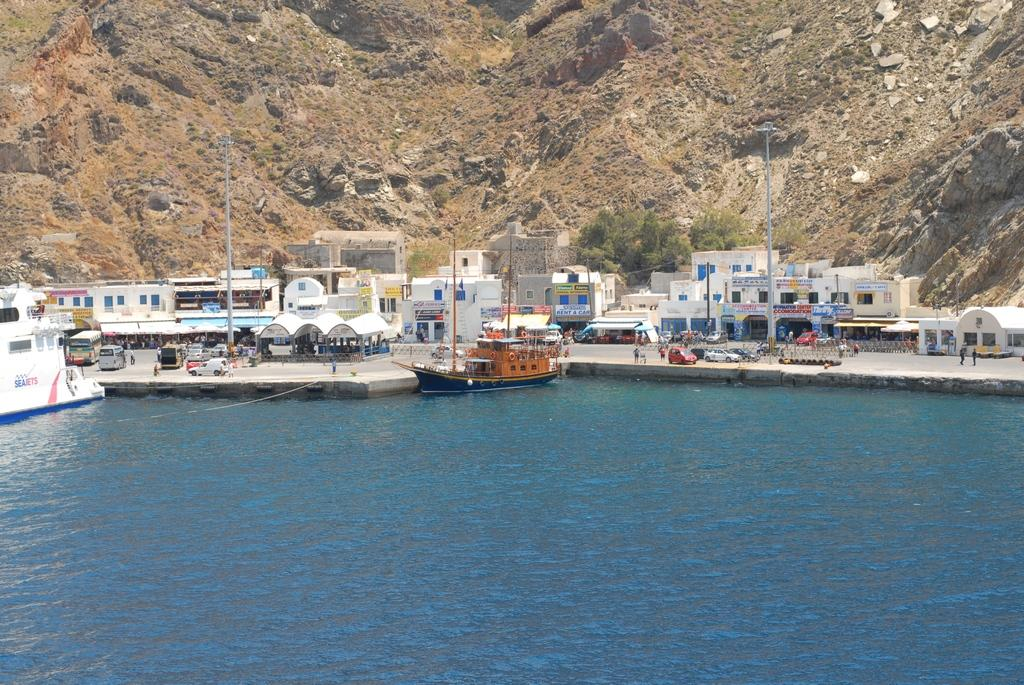What is on the water in the image? There are ships on the water in the image. What structures can be seen in the image? There are buildings visible in the image. What type of transportation is present in the image? Vehicles are present in the image. Who or what is on the ground in the image? There are people on the ground in the image. What are the tall, thin objects in the image? There are poles in the image. What type of lighting is visible in the image? Street lights are visible in the image. What geographical feature is present in the image? There is a mountain in the image. Where is the bed located in the image? There is no bed present in the image. What type of debt is being discussed in the image? There is no discussion of debt in the image. What is the purpose of the scissors in the image? There are no scissors present in the image. 